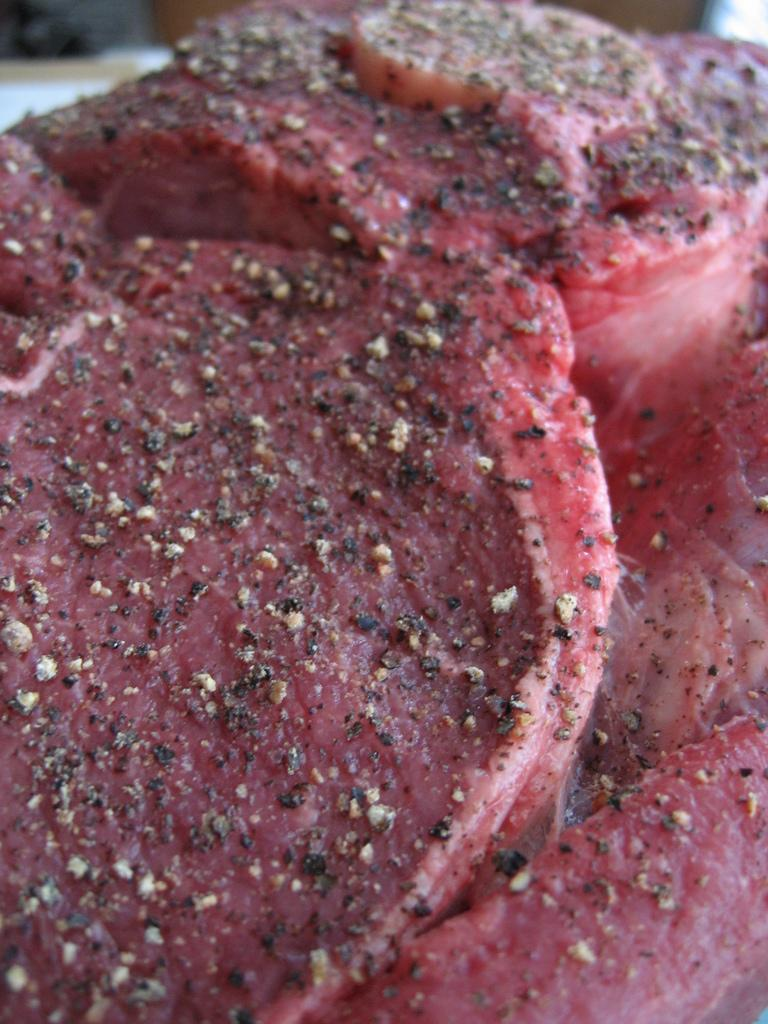What type of food is the main subject of the image? There is brisket in the image. Where is the brisket located in the image? The brisket is in the center of the image. What is on top of the brisket? There are spices on the brisket. What type of list can be seen next to the brisket in the image? There is no list present in the image; it only features brisket with spices on top. 